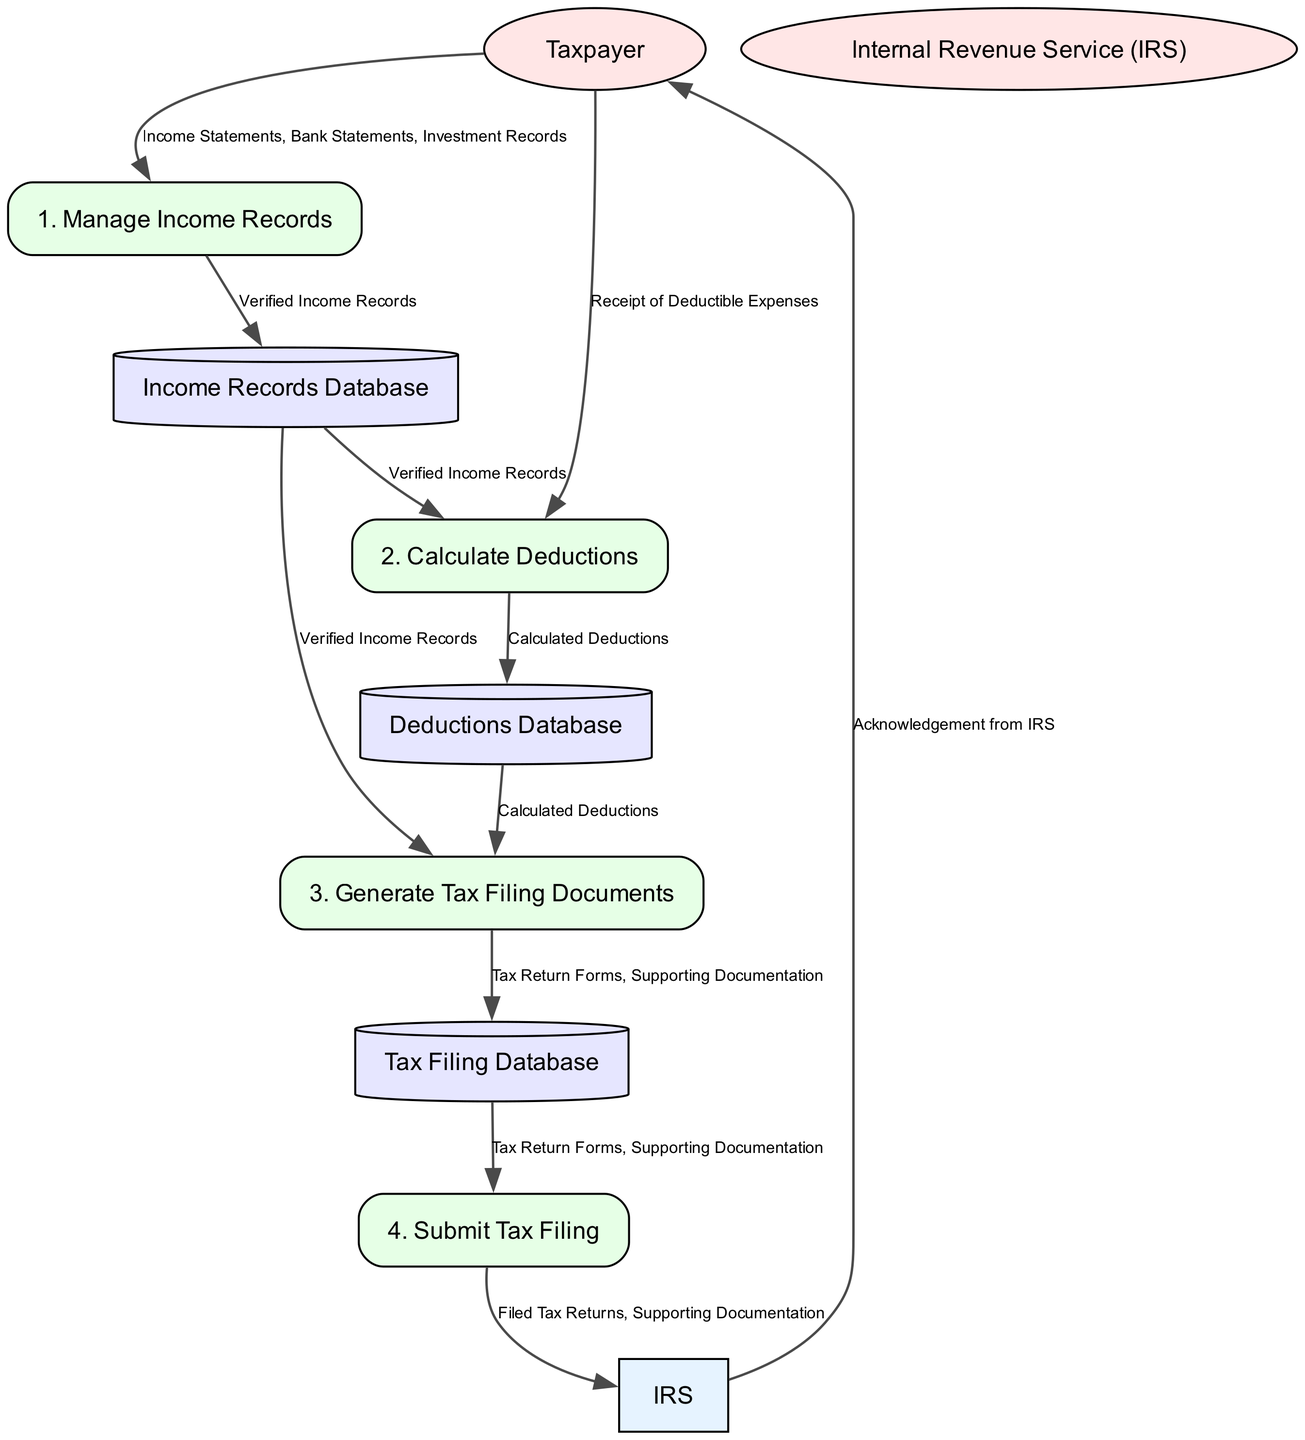What is the first process in the Tax Filing System? The first process in the diagram is identified by its ID, which is listed first as "1. Manage Income Records." This can be confirmed by looking at the order in which the processes are arranged in the diagram.
Answer: Manage Income Records Which external entity is involved in submitting tax filings? The external entity involved in submitting tax filings is represented in the diagram with the flow going to "IRS" as it receives the "Filed Tax Returns" and "Supporting Documentation." This indicates its role in the submission process.
Answer: IRS How many data stores are present in the diagram? By counting the nodes labeled as data stores in the diagram, there are three identified: "Income Records Database," "Deductions Database," and "Tax Filing Database." This count confirms the total number of data stores.
Answer: 3 What is the output of the process "Calculate Deductions"? The output of the "Calculate Deductions" process is "Calculated Deductions," as specified in the outputs section of this process. This can be found by checking the details related to this particular process node.
Answer: Calculated Deductions What data flows from "Tax Filing Database" to the process "Submit Tax Filing"? The data flowing from "Tax Filing Database" to "Submit Tax Filing" consists of "Tax Return Forms" and "Supporting Documentation." This relationship is indicated by the directed edge connecting these two entities in the diagram.
Answer: Tax Return Forms, Supporting Documentation What are the inputs for the "Generate Tax Filing Documents" process? The inputs required for the "Generate Tax Filing Documents" process include "Verified Income Records" and "Calculated Deductions." This can be confirmed by examining the inputs section of the diagram for this particular process.
Answer: Verified Income Records, Calculated Deductions Which external entity receives an acknowledgment from the IRS? The external entity that receives an acknowledgment from the IRS is the "Taxpayer." This is shown in the last flow that goes from "IRS" back to "Taxpayer."
Answer: Taxpayer Identify the process that manages all verified income records. The process responsible for managing all verified income records is the "Manage Income Records," as it specifically mentions handling income records and outputs "Verified Income Records." This can be observed directly from the process details in the diagram.
Answer: Manage Income Records What is the last process in the tax filing flow? The last process in the tax filing flow is "Submit Tax Filing." It is positioned at the end of the directional flows illustrating the overall sequence of tax filing actions.
Answer: Submit Tax Filing 